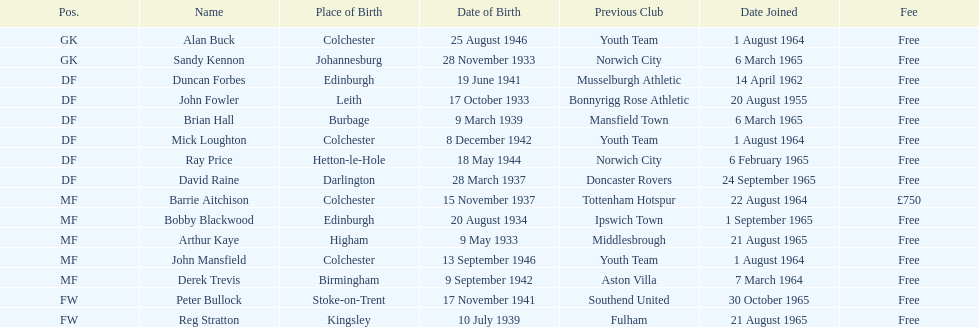Is arthur kaye elder or junior to brian hill? Older. 